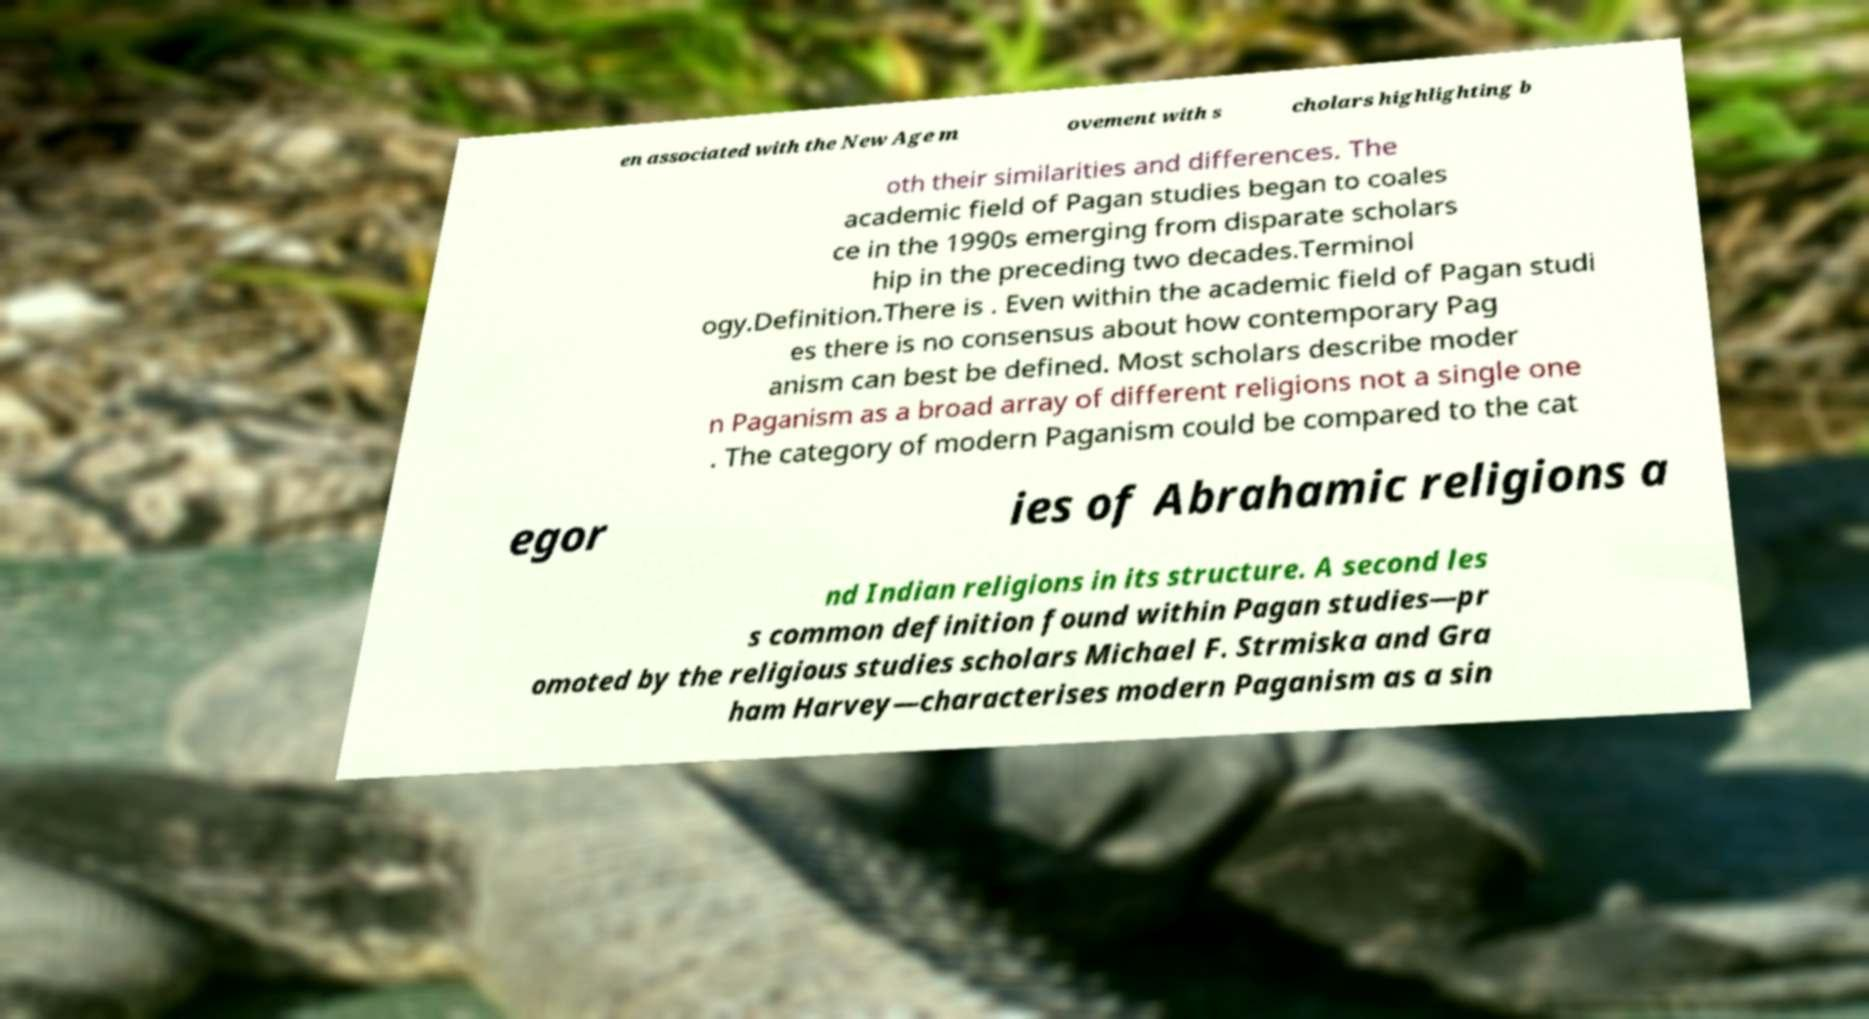Could you assist in decoding the text presented in this image and type it out clearly? en associated with the New Age m ovement with s cholars highlighting b oth their similarities and differences. The academic field of Pagan studies began to coales ce in the 1990s emerging from disparate scholars hip in the preceding two decades.Terminol ogy.Definition.There is . Even within the academic field of Pagan studi es there is no consensus about how contemporary Pag anism can best be defined. Most scholars describe moder n Paganism as a broad array of different religions not a single one . The category of modern Paganism could be compared to the cat egor ies of Abrahamic religions a nd Indian religions in its structure. A second les s common definition found within Pagan studies—pr omoted by the religious studies scholars Michael F. Strmiska and Gra ham Harvey—characterises modern Paganism as a sin 